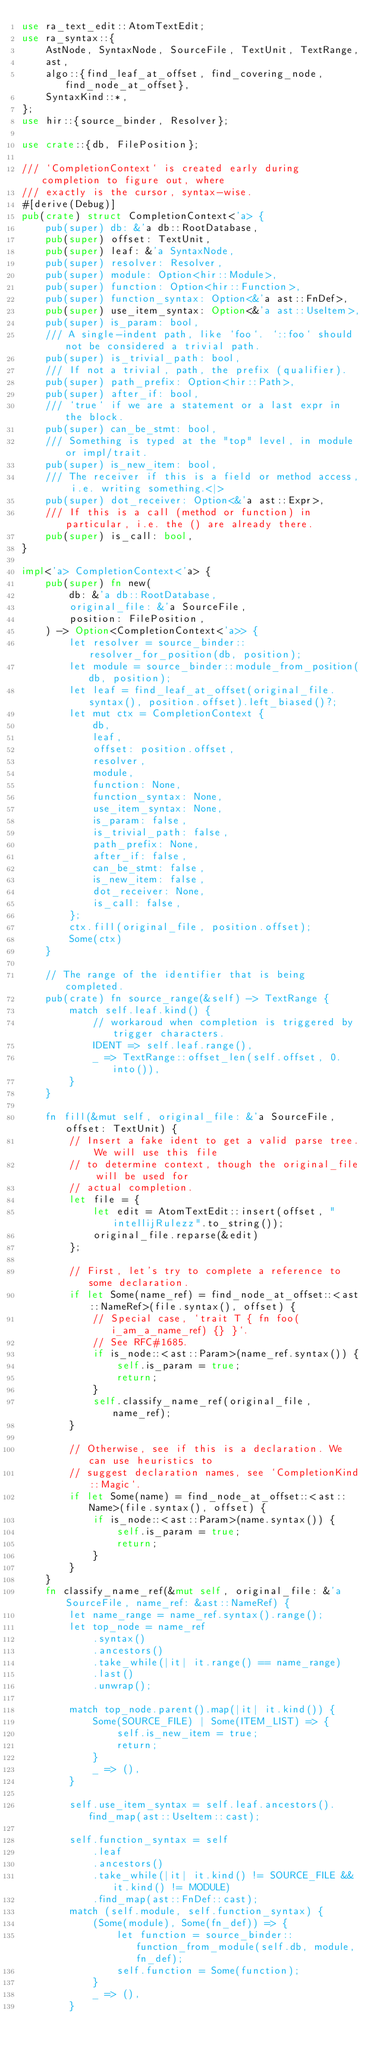Convert code to text. <code><loc_0><loc_0><loc_500><loc_500><_Rust_>use ra_text_edit::AtomTextEdit;
use ra_syntax::{
    AstNode, SyntaxNode, SourceFile, TextUnit, TextRange,
    ast,
    algo::{find_leaf_at_offset, find_covering_node, find_node_at_offset},
    SyntaxKind::*,
};
use hir::{source_binder, Resolver};

use crate::{db, FilePosition};

/// `CompletionContext` is created early during completion to figure out, where
/// exactly is the cursor, syntax-wise.
#[derive(Debug)]
pub(crate) struct CompletionContext<'a> {
    pub(super) db: &'a db::RootDatabase,
    pub(super) offset: TextUnit,
    pub(super) leaf: &'a SyntaxNode,
    pub(super) resolver: Resolver,
    pub(super) module: Option<hir::Module>,
    pub(super) function: Option<hir::Function>,
    pub(super) function_syntax: Option<&'a ast::FnDef>,
    pub(super) use_item_syntax: Option<&'a ast::UseItem>,
    pub(super) is_param: bool,
    /// A single-indent path, like `foo`. `::foo` should not be considered a trivial path.
    pub(super) is_trivial_path: bool,
    /// If not a trivial, path, the prefix (qualifier).
    pub(super) path_prefix: Option<hir::Path>,
    pub(super) after_if: bool,
    /// `true` if we are a statement or a last expr in the block.
    pub(super) can_be_stmt: bool,
    /// Something is typed at the "top" level, in module or impl/trait.
    pub(super) is_new_item: bool,
    /// The receiver if this is a field or method access, i.e. writing something.<|>
    pub(super) dot_receiver: Option<&'a ast::Expr>,
    /// If this is a call (method or function) in particular, i.e. the () are already there.
    pub(super) is_call: bool,
}

impl<'a> CompletionContext<'a> {
    pub(super) fn new(
        db: &'a db::RootDatabase,
        original_file: &'a SourceFile,
        position: FilePosition,
    ) -> Option<CompletionContext<'a>> {
        let resolver = source_binder::resolver_for_position(db, position);
        let module = source_binder::module_from_position(db, position);
        let leaf = find_leaf_at_offset(original_file.syntax(), position.offset).left_biased()?;
        let mut ctx = CompletionContext {
            db,
            leaf,
            offset: position.offset,
            resolver,
            module,
            function: None,
            function_syntax: None,
            use_item_syntax: None,
            is_param: false,
            is_trivial_path: false,
            path_prefix: None,
            after_if: false,
            can_be_stmt: false,
            is_new_item: false,
            dot_receiver: None,
            is_call: false,
        };
        ctx.fill(original_file, position.offset);
        Some(ctx)
    }

    // The range of the identifier that is being completed.
    pub(crate) fn source_range(&self) -> TextRange {
        match self.leaf.kind() {
            // workaroud when completion is triggered by trigger characters.
            IDENT => self.leaf.range(),
            _ => TextRange::offset_len(self.offset, 0.into()),
        }
    }

    fn fill(&mut self, original_file: &'a SourceFile, offset: TextUnit) {
        // Insert a fake ident to get a valid parse tree. We will use this file
        // to determine context, though the original_file will be used for
        // actual completion.
        let file = {
            let edit = AtomTextEdit::insert(offset, "intellijRulezz".to_string());
            original_file.reparse(&edit)
        };

        // First, let's try to complete a reference to some declaration.
        if let Some(name_ref) = find_node_at_offset::<ast::NameRef>(file.syntax(), offset) {
            // Special case, `trait T { fn foo(i_am_a_name_ref) {} }`.
            // See RFC#1685.
            if is_node::<ast::Param>(name_ref.syntax()) {
                self.is_param = true;
                return;
            }
            self.classify_name_ref(original_file, name_ref);
        }

        // Otherwise, see if this is a declaration. We can use heuristics to
        // suggest declaration names, see `CompletionKind::Magic`.
        if let Some(name) = find_node_at_offset::<ast::Name>(file.syntax(), offset) {
            if is_node::<ast::Param>(name.syntax()) {
                self.is_param = true;
                return;
            }
        }
    }
    fn classify_name_ref(&mut self, original_file: &'a SourceFile, name_ref: &ast::NameRef) {
        let name_range = name_ref.syntax().range();
        let top_node = name_ref
            .syntax()
            .ancestors()
            .take_while(|it| it.range() == name_range)
            .last()
            .unwrap();

        match top_node.parent().map(|it| it.kind()) {
            Some(SOURCE_FILE) | Some(ITEM_LIST) => {
                self.is_new_item = true;
                return;
            }
            _ => (),
        }

        self.use_item_syntax = self.leaf.ancestors().find_map(ast::UseItem::cast);

        self.function_syntax = self
            .leaf
            .ancestors()
            .take_while(|it| it.kind() != SOURCE_FILE && it.kind() != MODULE)
            .find_map(ast::FnDef::cast);
        match (self.module, self.function_syntax) {
            (Some(module), Some(fn_def)) => {
                let function = source_binder::function_from_module(self.db, module, fn_def);
                self.function = Some(function);
            }
            _ => (),
        }
</code> 